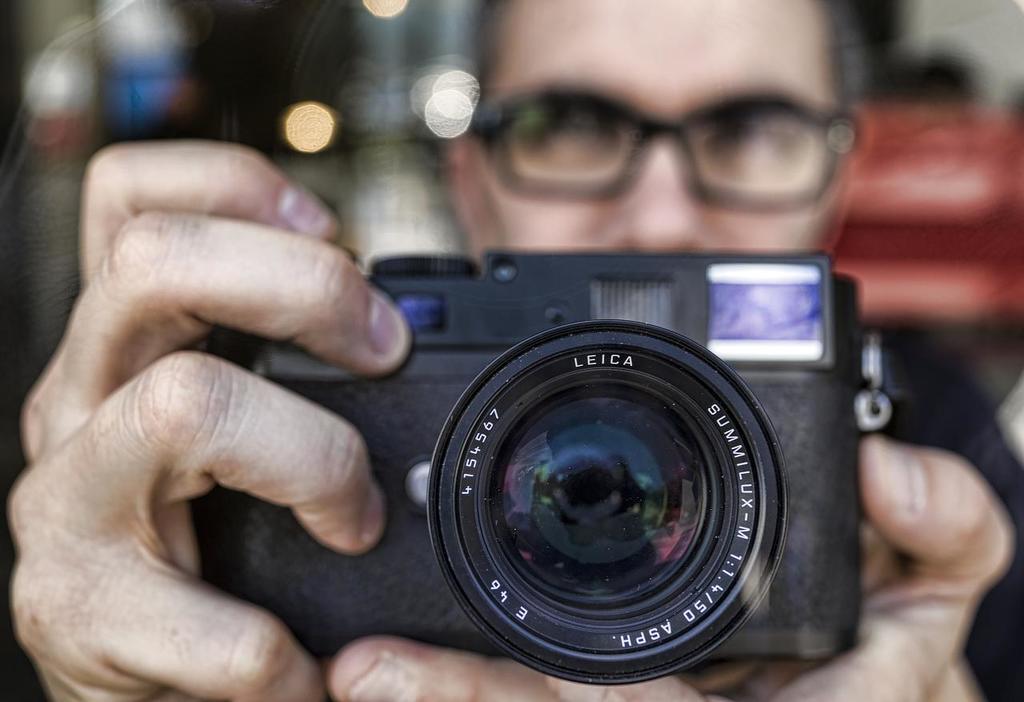Can you describe this image briefly? In this picture there is a man holding the camera. 